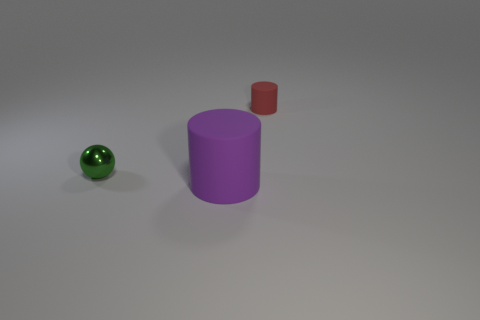Subtract all balls. How many objects are left? 2 Add 3 red objects. How many objects exist? 6 Subtract 0 green cylinders. How many objects are left? 3 Subtract all large green shiny blocks. Subtract all tiny things. How many objects are left? 1 Add 3 large purple cylinders. How many large purple cylinders are left? 4 Add 3 purple rubber things. How many purple rubber things exist? 4 